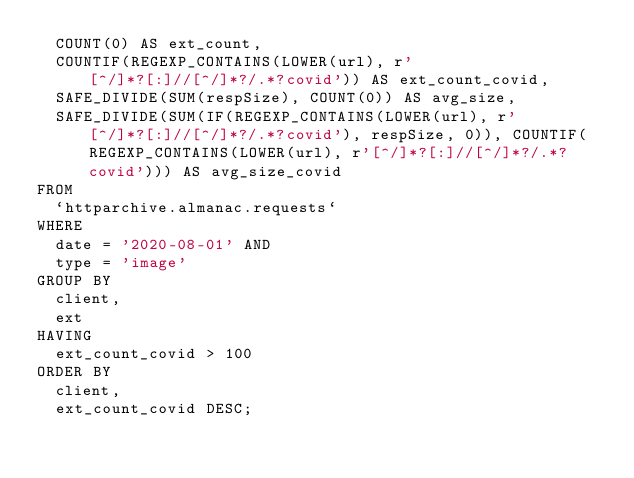<code> <loc_0><loc_0><loc_500><loc_500><_SQL_>  COUNT(0) AS ext_count,
  COUNTIF(REGEXP_CONTAINS(LOWER(url), r'[^/]*?[:]//[^/]*?/.*?covid')) AS ext_count_covid,
  SAFE_DIVIDE(SUM(respSize), COUNT(0)) AS avg_size,
  SAFE_DIVIDE(SUM(IF(REGEXP_CONTAINS(LOWER(url), r'[^/]*?[:]//[^/]*?/.*?covid'), respSize, 0)), COUNTIF(REGEXP_CONTAINS(LOWER(url), r'[^/]*?[:]//[^/]*?/.*?covid'))) AS avg_size_covid
FROM
  `httparchive.almanac.requests`
WHERE
  date = '2020-08-01' AND
  type = 'image'
GROUP BY
  client,
  ext
HAVING
  ext_count_covid > 100
ORDER BY
  client,
  ext_count_covid DESC;
</code> 